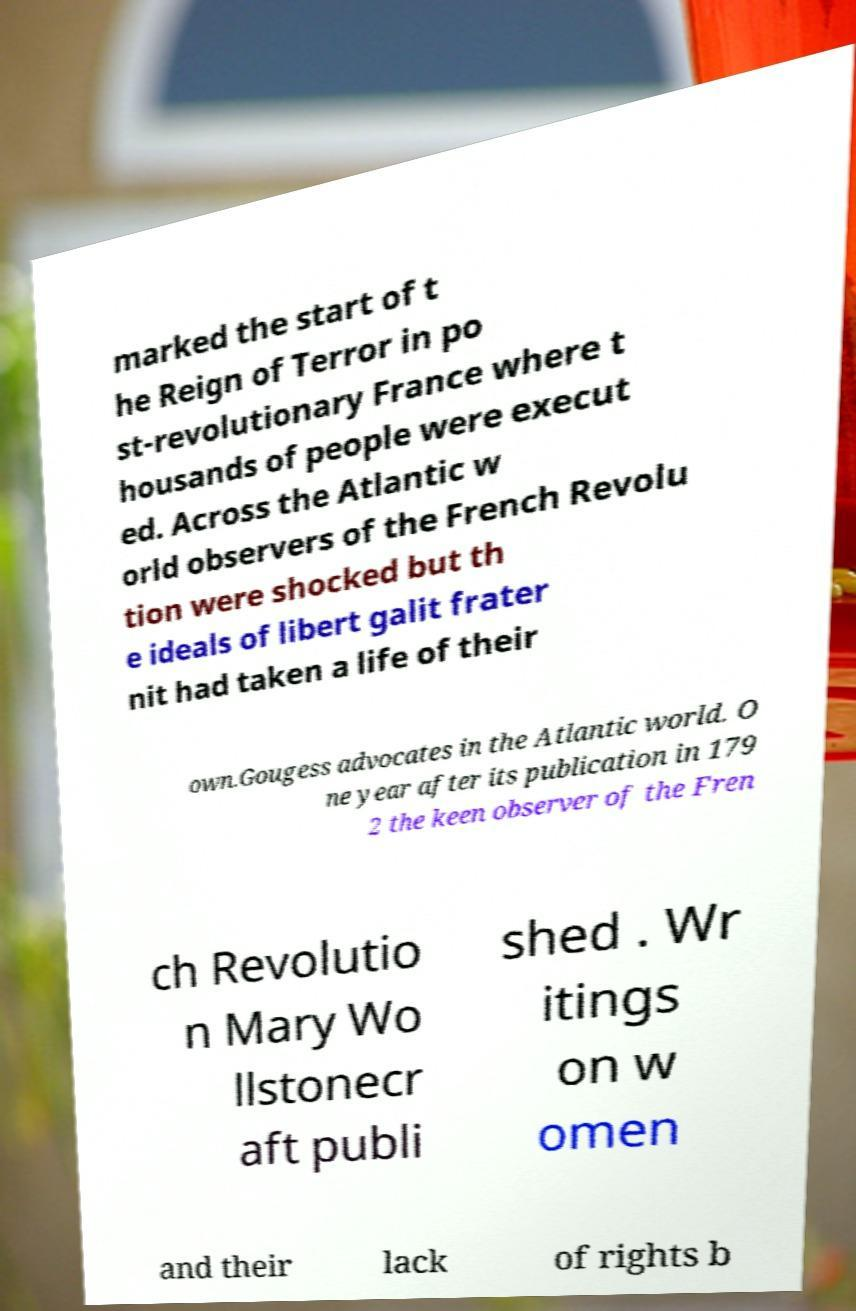Please identify and transcribe the text found in this image. marked the start of t he Reign of Terror in po st-revolutionary France where t housands of people were execut ed. Across the Atlantic w orld observers of the French Revolu tion were shocked but th e ideals of libert galit frater nit had taken a life of their own.Gougess advocates in the Atlantic world. O ne year after its publication in 179 2 the keen observer of the Fren ch Revolutio n Mary Wo llstonecr aft publi shed . Wr itings on w omen and their lack of rights b 